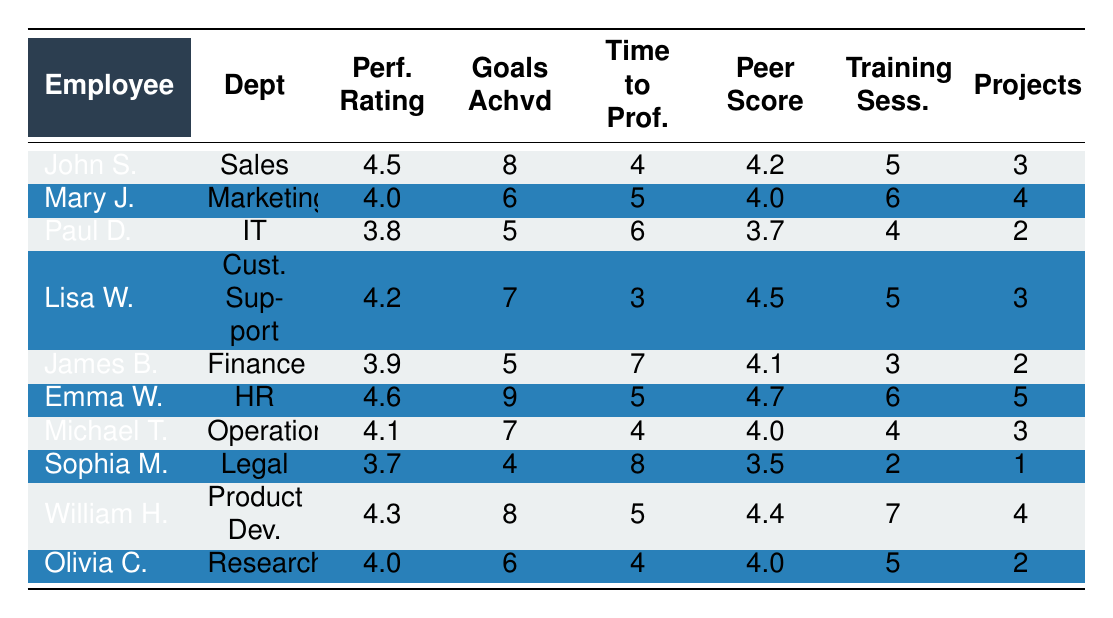What is the performance rating of John Smith? The performance rating for John Smith, as indicated in the table, is found in the "Perf. Rating" column for his row. It shows 4.5.
Answer: 4.5 Which department does Emma Wilson work in? Looking at the "Dept" column for the row corresponding to Emma Wilson, it indicates that she works in the Human Resources department.
Answer: Human Resources How many goals did William Hernandez achieve? The "Goals Achvd" column for William Hernandez shows that he achieved 8 goals.
Answer: 8 What is the average performance rating of all the employees listed? The performance ratings are 4.5, 4.0, 3.8, 4.2, 3.9, 4.6, 4.1, 3.7, 4.3, and 4.0. Adding these up gives 43.1. Dividing by the number of employees (10) results in an average performance rating of 4.31.
Answer: 4.31 Is Lisa Wilson's peer feedback score higher than that of Michael Taylor? Lisa Wilson's peer feedback score is 4.5, while Michael Taylor's score is 4.0. Since 4.5 is greater than 4.0, the answer is yes.
Answer: Yes Which employee has the highest number of training sessions attended? Reviewing the "Training Sess." column, the highest value is found for Emma Wilson with 6 sessions. This means she attended more sessions than anyone else in the table.
Answer: 6 What is the time to full proficiency of Paul Davis, and is it greater than 5 months? Paul Davis's "Time to Prof." is listed as 6 months. Since 6 is greater than 5, we can confirm that it is indeed greater than that period.
Answer: Yes How many projects did the employee from the Legal department work on? In the row for the employee from the Legal department (Sophia Martinez), the "Projects" column shows that she worked on 1 project.
Answer: 1 What is the median number of goals achieved by the new hires? The goals achieved are: 8, 6, 5, 7, 5, 9, 7, 4, 8, and 6. When sorted, the values are 4, 5, 5, 6, 6, 7, 7, 8, 8, 9. The median is the average of the two middle numbers (6 and 6), which is 6.
Answer: 6 Which two employees have the lowest performance ratings, and what are their ratings? The performance ratings are reviewed, and the lowest are Paul Davis at 3.8 and Sophia Martinez at 3.7. They are the two employees with the least performance rating in the table.
Answer: Paul Davis: 3.8, Sophia Martinez: 3.7 